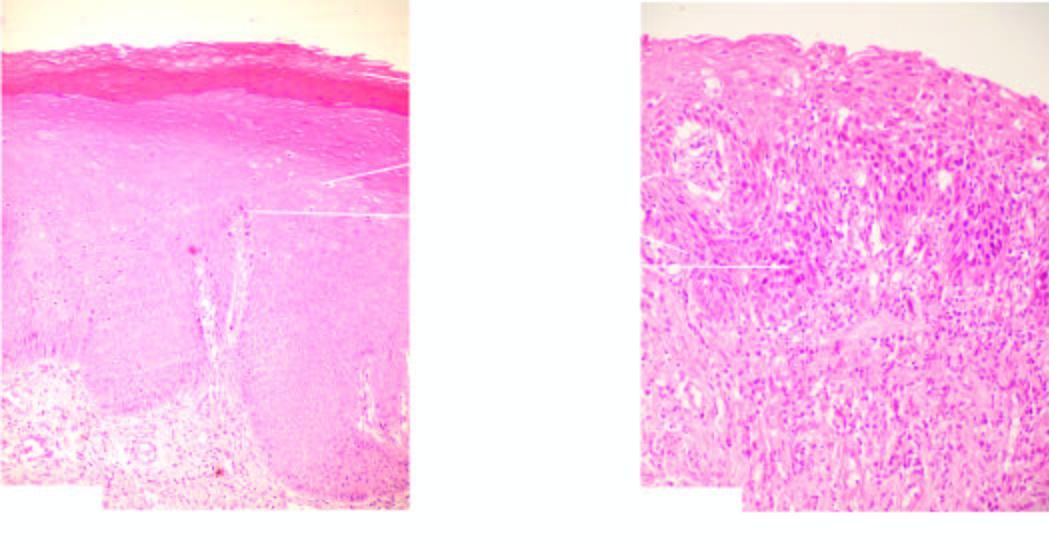s the pleural surface of the specimen of the lung increased?
Answer the question using a single word or phrase. No 